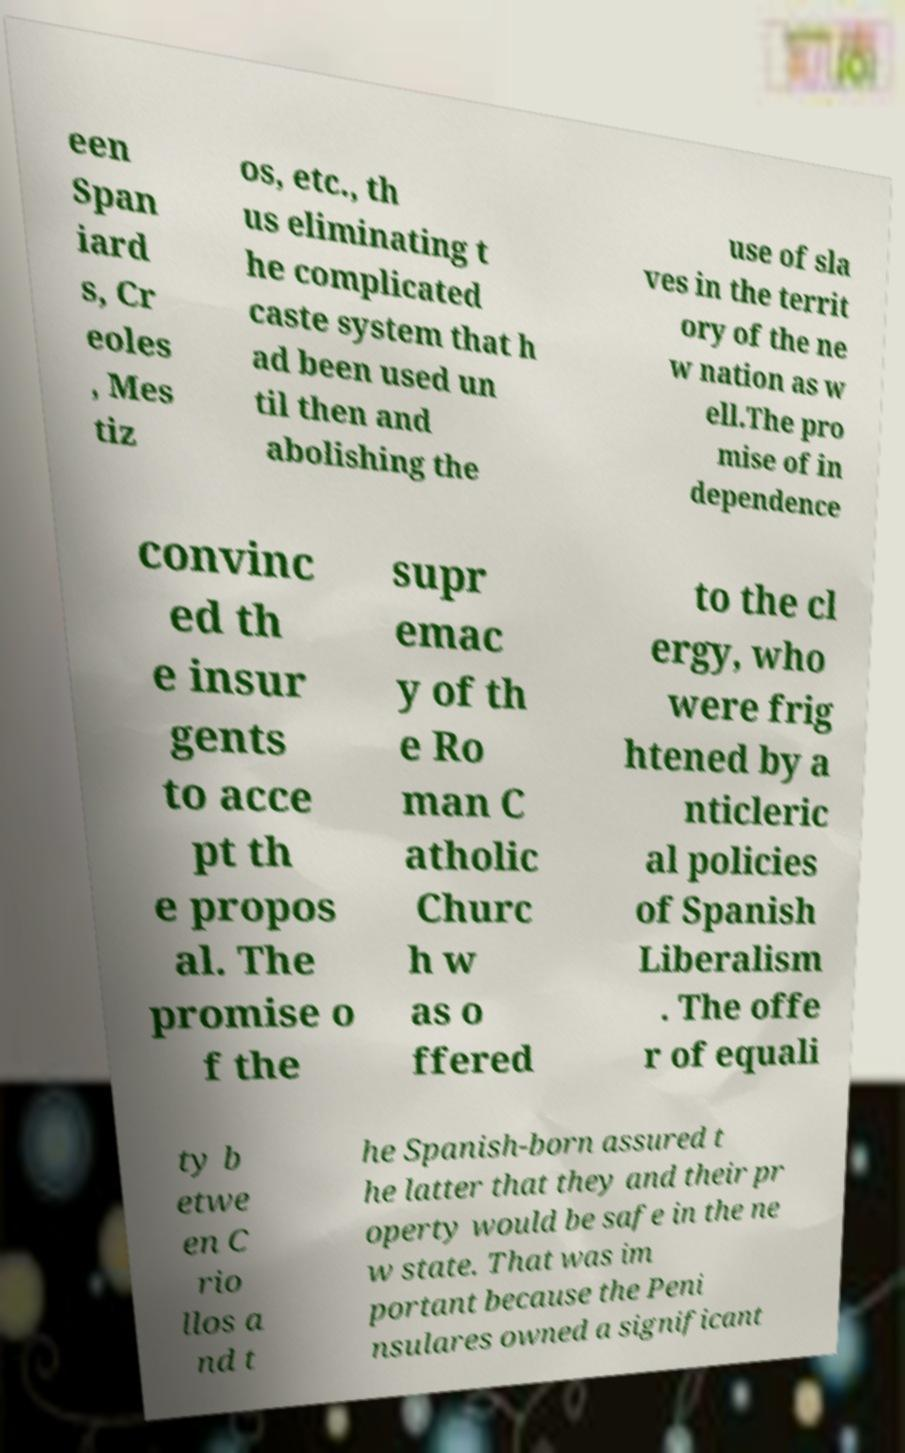There's text embedded in this image that I need extracted. Can you transcribe it verbatim? een Span iard s, Cr eoles , Mes tiz os, etc., th us eliminating t he complicated caste system that h ad been used un til then and abolishing the use of sla ves in the territ ory of the ne w nation as w ell.The pro mise of in dependence convinc ed th e insur gents to acce pt th e propos al. The promise o f the supr emac y of th e Ro man C atholic Churc h w as o ffered to the cl ergy, who were frig htened by a nticleric al policies of Spanish Liberalism . The offe r of equali ty b etwe en C rio llos a nd t he Spanish-born assured t he latter that they and their pr operty would be safe in the ne w state. That was im portant because the Peni nsulares owned a significant 